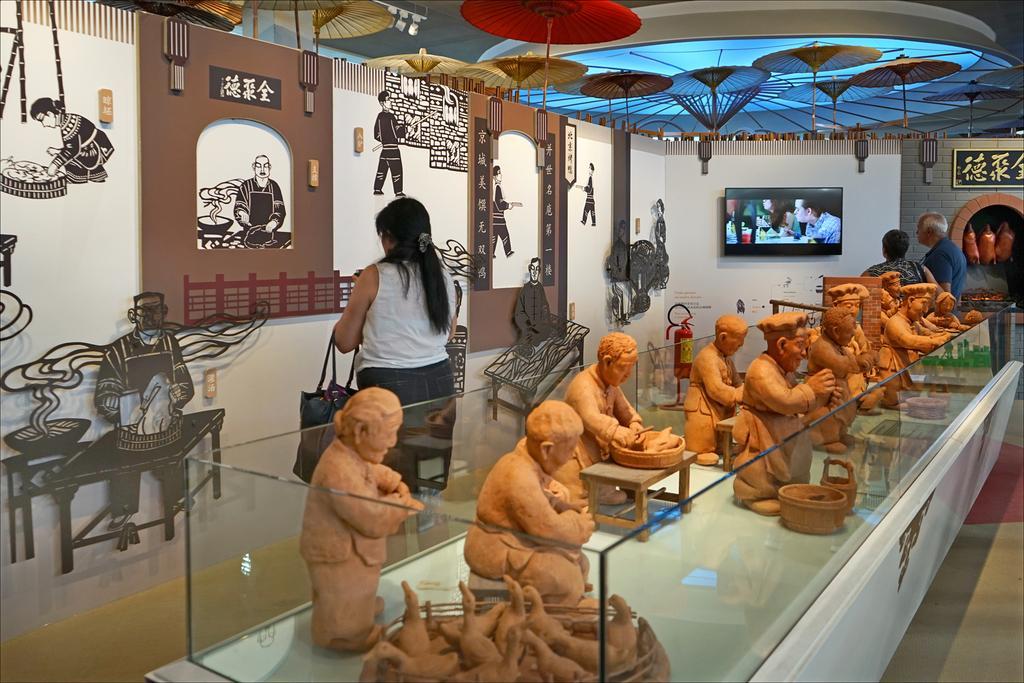In one or two sentences, can you explain what this image depicts? In this image there are sculptures on the table. There is a glass box around them. Behind the table there are a few people standing. In front of them there is a wall. There are sculptures on the wall. In the background there is a television on the wall. At the top there are decorative things hanging to the ceiling. 